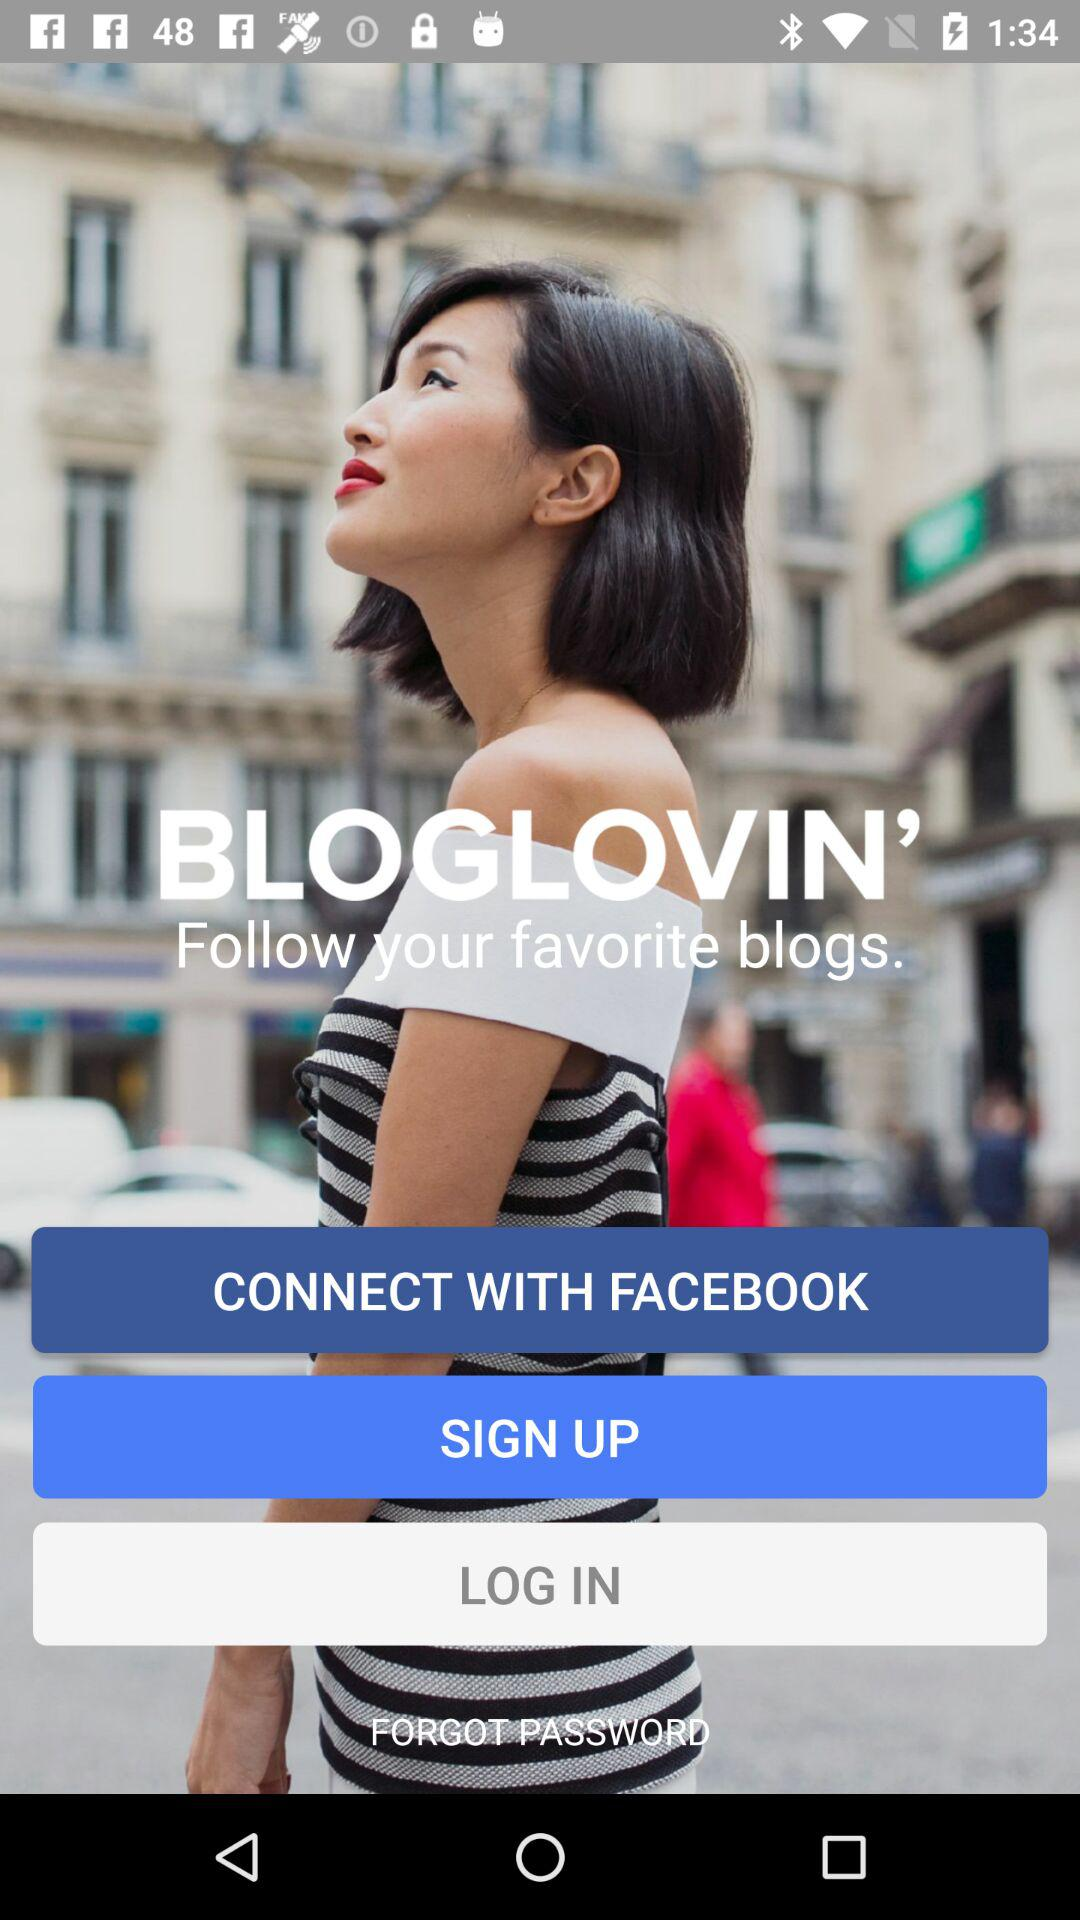Through what account can the user connect? The user can connect through the "FACEBOOK" account. 